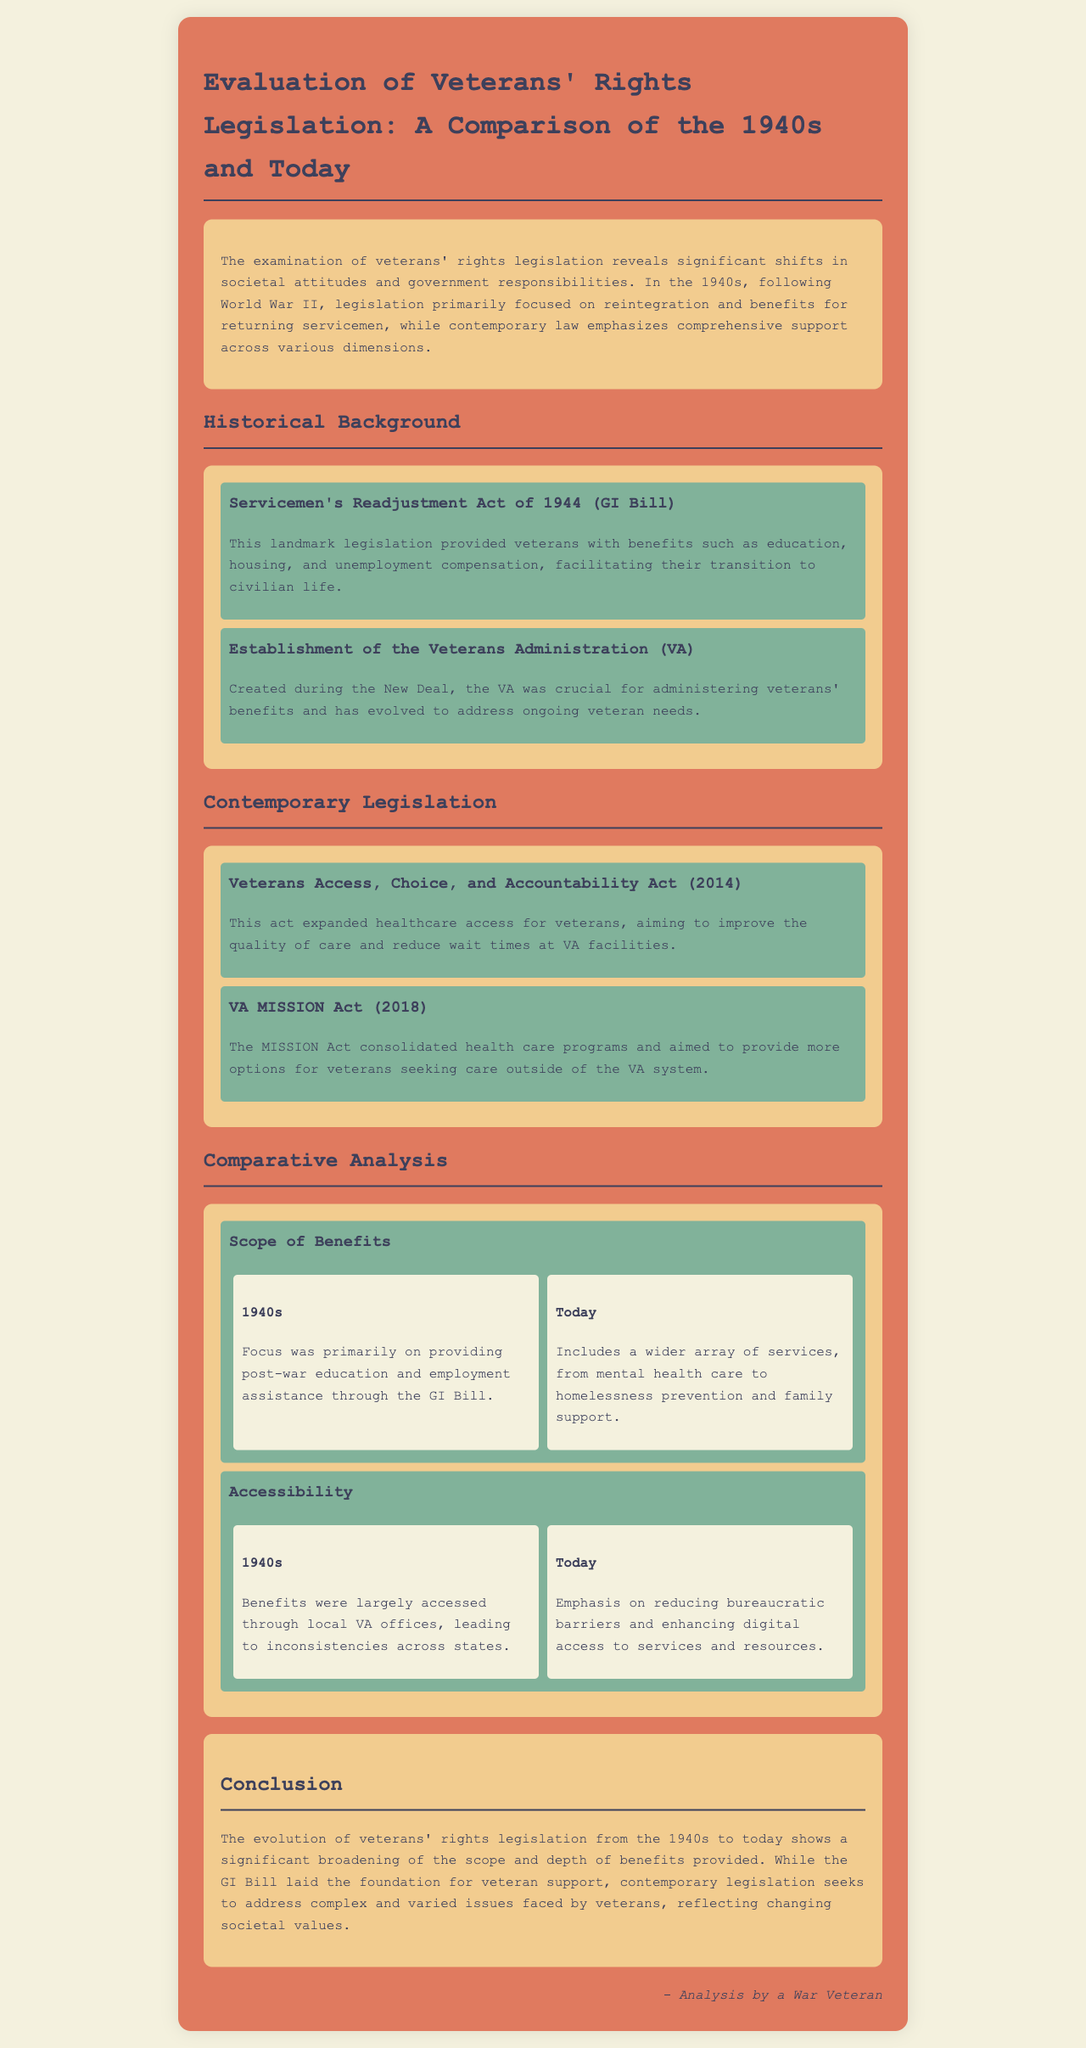What is the landmark legislation passed in 1944? The landmark legislation is the Servicemen's Readjustment Act of 1944, commonly known as the GI Bill.
Answer: Servicemen's Readjustment Act of 1944 (GI Bill) What does the VA stand for? In the context of the document, VA stands for Veterans Administration.
Answer: Veterans Administration How many contemporary laws are mentioned in the document? The document mentions two contemporary laws regarding veterans' rights legislation.
Answer: Two What aspect of veterans' benefits does the 1940s focus on? The focus of veterans' benefits in the 1940s was primarily on education and employment assistance.
Answer: Education and employment assistance What is a key feature of the Veterans Access, Choice, and Accountability Act? A key feature of this act is its aim to expand healthcare access for veterans.
Answer: Expand healthcare access How does the accessibility of benefits differ from the 1940s to today? In the 1940s, benefits were accessed through local VA offices, while today there is an emphasis on reducing bureaucratic barriers.
Answer: Local VA offices vs. reducing bureaucratic barriers What does the VA MISSION Act aim to consolidate? The VA MISSION Act aims to consolidate health care programs for veterans.
Answer: Health care programs What was a primary societal attitude reflected in the 1940s legislation? The primary societal attitude reflected was a focus on reintegration and benefits for returning servicemen.
Answer: Focus on reintegration and benefits 